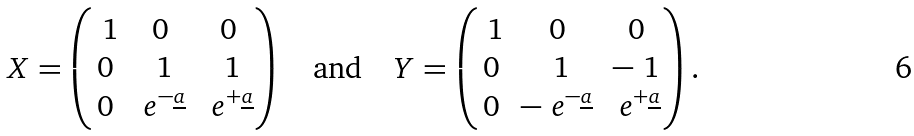<formula> <loc_0><loc_0><loc_500><loc_500>X = \begin{pmatrix} \ 1 & 0 & 0 \\ 0 & \ 1 & \ 1 \\ 0 & \ e ^ { - \underline { a } } & \ e ^ { + \underline { a } } \end{pmatrix} \quad \text {and} \quad Y = \begin{pmatrix} \ 1 & 0 & 0 \\ 0 & \ 1 & - \ 1 \\ 0 & - \ e ^ { - \underline { a } } & \ e ^ { + \underline { a } } \end{pmatrix} .</formula> 